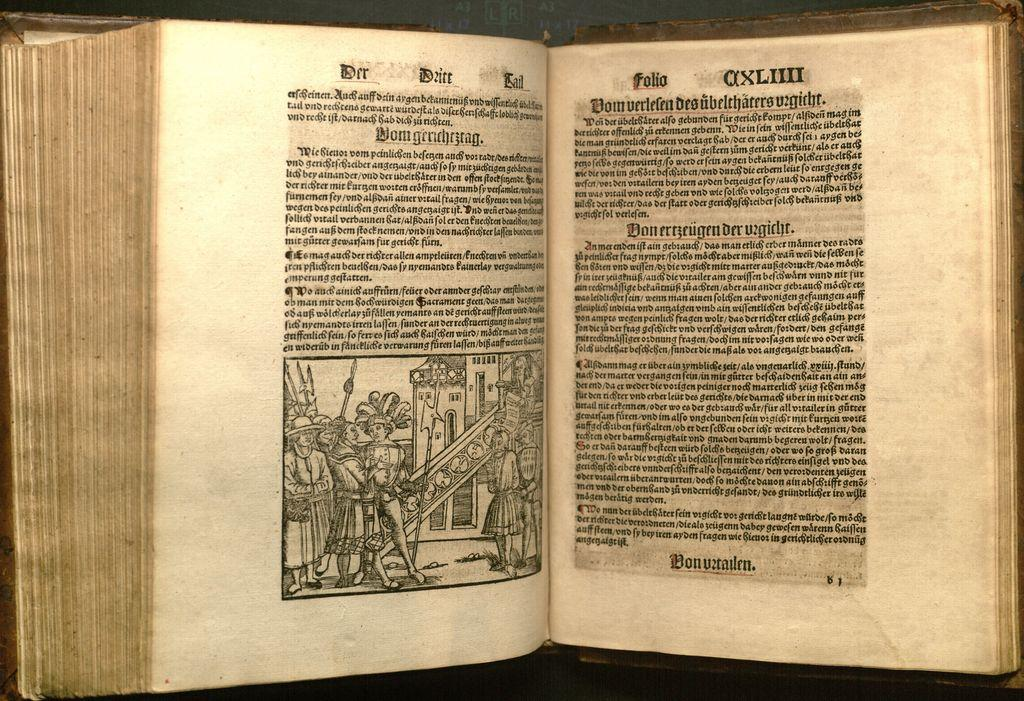Provide a one-sentence caption for the provided image. An ancient German book has a paragraph titled Domgrrichezrag. 